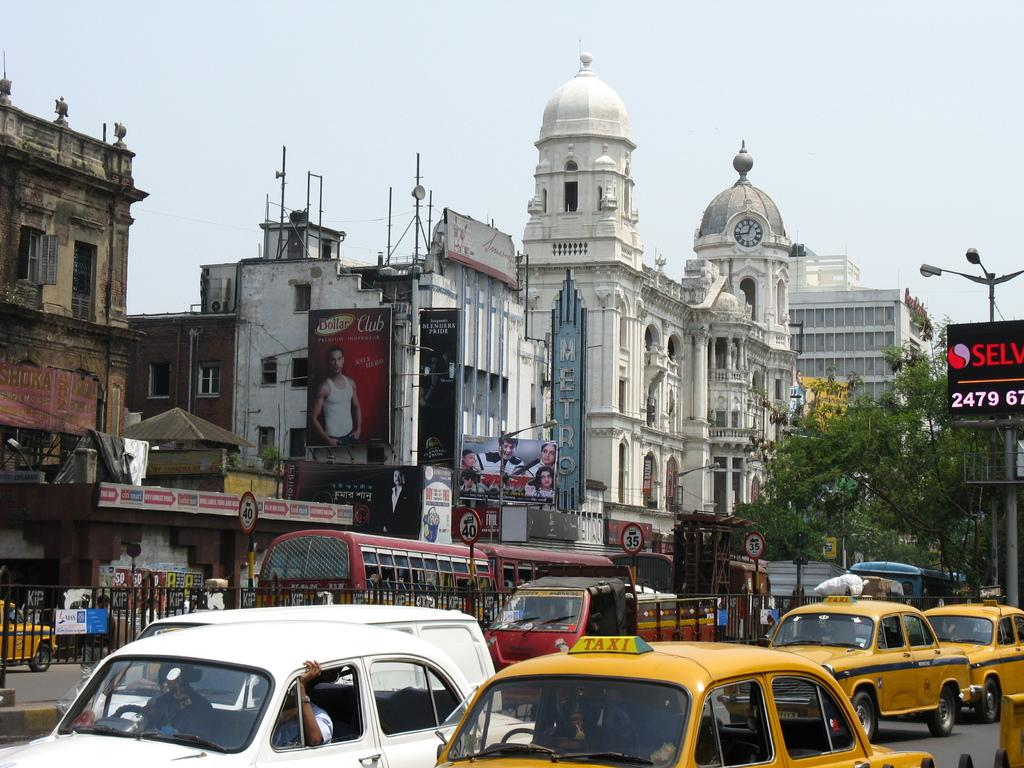<image>
Describe the image concisely. A few taxis are driving down a street in a city. 